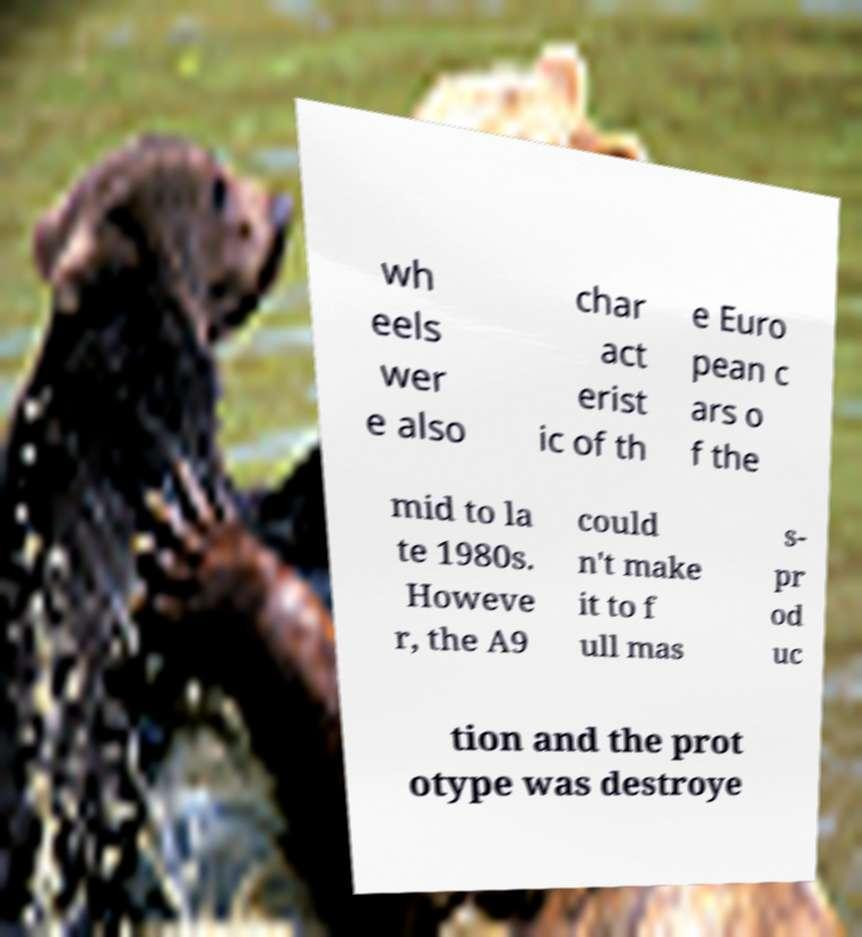Could you assist in decoding the text presented in this image and type it out clearly? wh eels wer e also char act erist ic of th e Euro pean c ars o f the mid to la te 1980s. Howeve r, the A9 could n't make it to f ull mas s- pr od uc tion and the prot otype was destroye 